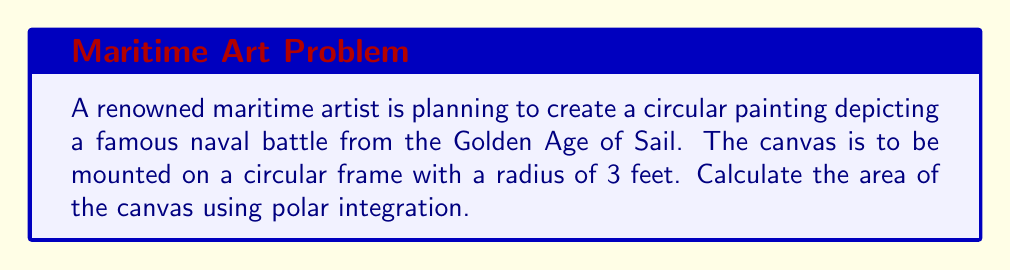Could you help me with this problem? To determine the area of the circular canvas, we can use polar integration. In polar coordinates, the area of a region is given by the formula:

$$ A = \int_{\theta_1}^{\theta_2} \int_{r_1}^{r_2} r \, dr \, d\theta $$

For a full circle:
1. The angle $\theta$ goes from 0 to $2\pi$
2. The radius $r$ goes from 0 to the given radius (3 feet)

Let's set up the integral:

$$ A = \int_{0}^{2\pi} \int_{0}^{3} r \, dr \, d\theta $$

Now, let's solve the inner integral first:

$$ A = \int_{0}^{2\pi} \left[ \frac{r^2}{2} \right]_{0}^{3} \, d\theta $$

$$ A = \int_{0}^{2\pi} \left( \frac{3^2}{2} - \frac{0^2}{2} \right) \, d\theta $$

$$ A = \int_{0}^{2\pi} \frac{9}{2} \, d\theta $$

Now, let's solve the outer integral:

$$ A = \frac{9}{2} \left[ \theta \right]_{0}^{2\pi} $$

$$ A = \frac{9}{2} (2\pi - 0) $$

$$ A = 9\pi $$

Therefore, the area of the circular canvas is $9\pi$ square feet.
Answer: $9\pi$ square feet 